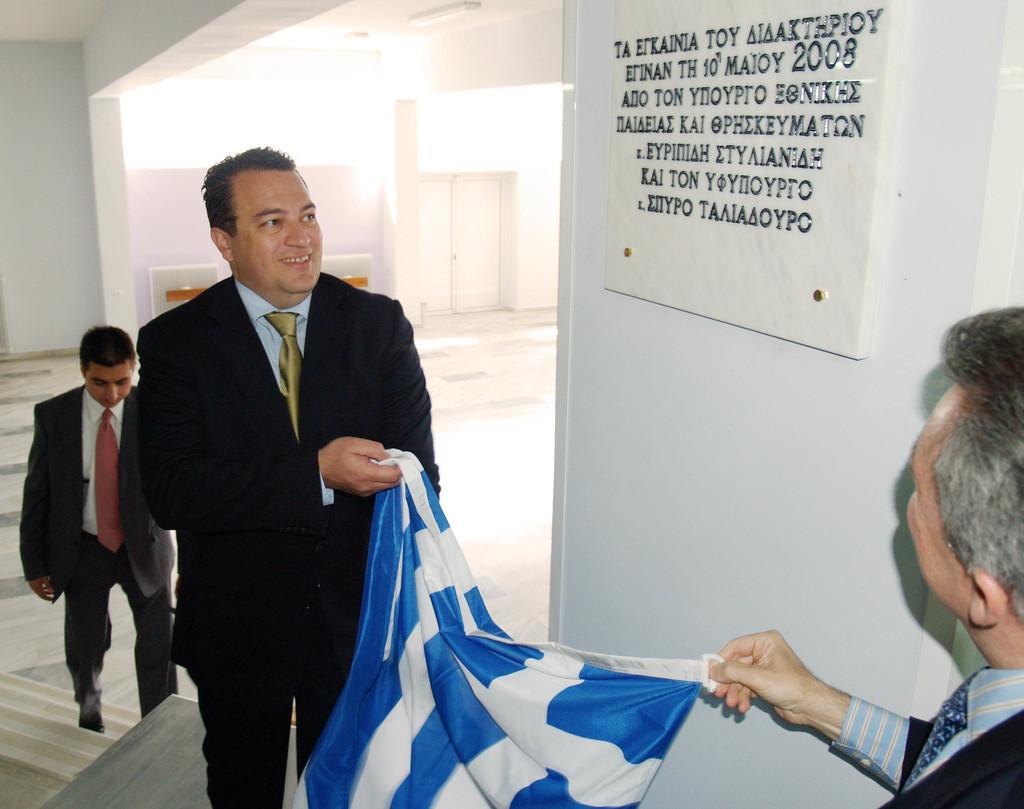Could you give a brief overview of what you see in this image? Board is on the white wall. These two people are holding clothes and looking at this board. Back Side we can see a person, wall and door. These three people wore suits and ties.  